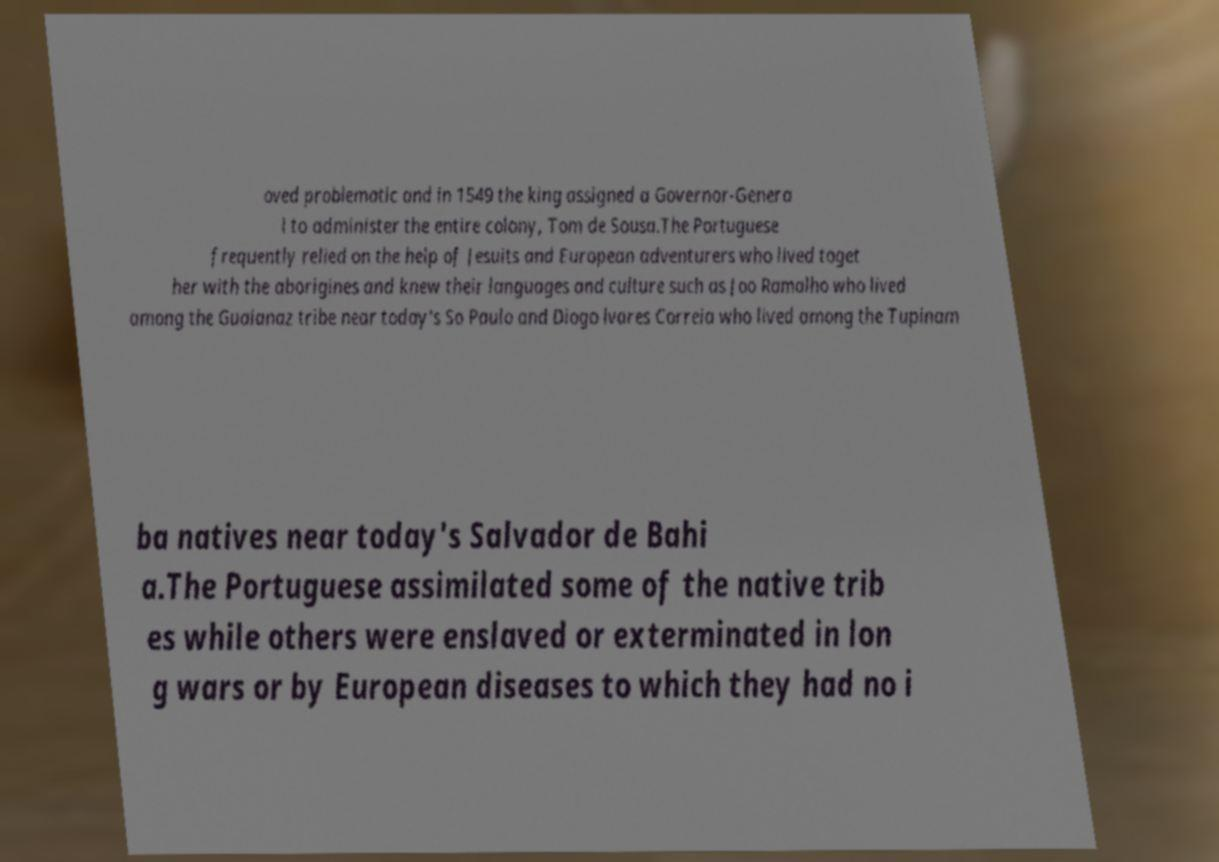Could you assist in decoding the text presented in this image and type it out clearly? oved problematic and in 1549 the king assigned a Governor-Genera l to administer the entire colony, Tom de Sousa.The Portuguese frequently relied on the help of Jesuits and European adventurers who lived toget her with the aborigines and knew their languages and culture such as Joo Ramalho who lived among the Guaianaz tribe near today's So Paulo and Diogo lvares Correia who lived among the Tupinam ba natives near today's Salvador de Bahi a.The Portuguese assimilated some of the native trib es while others were enslaved or exterminated in lon g wars or by European diseases to which they had no i 